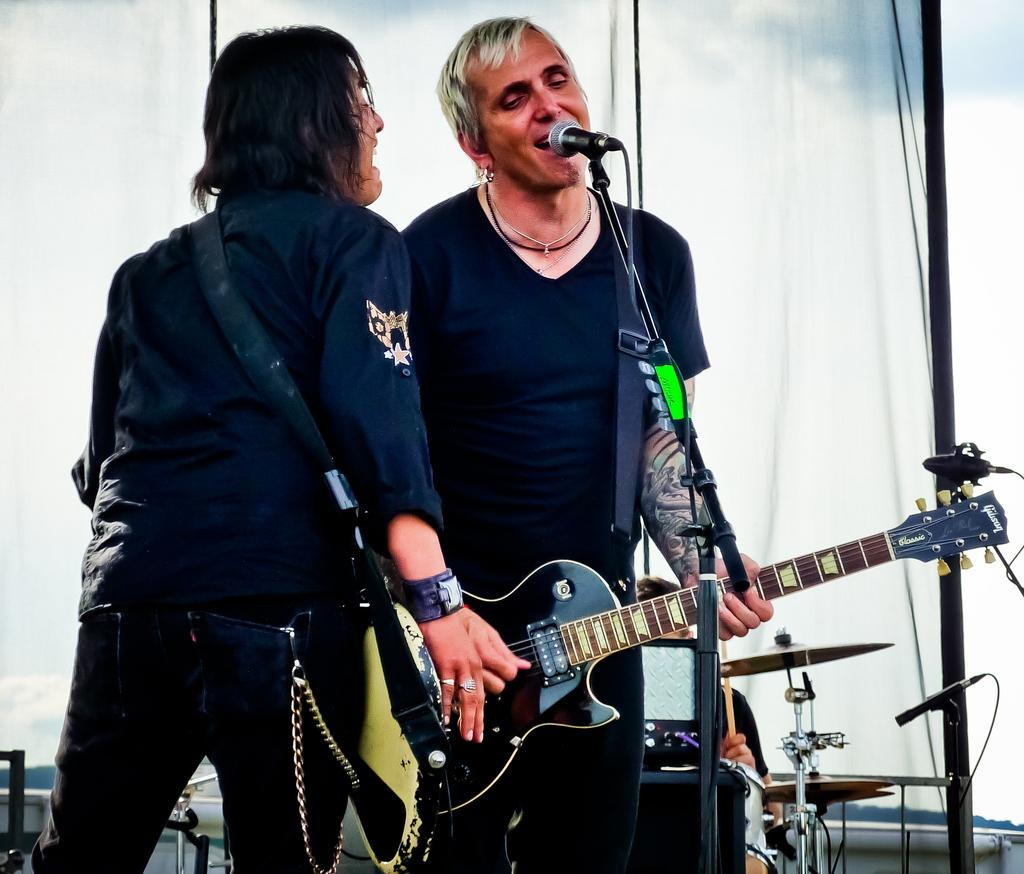How many people are in the image? There are two persons in the image. Where are the two persons located? The two persons are standing on a stage. What are the two persons doing on the stage? Both persons are playing musical instruments. Are there any fairies participating in the protest with the women in the image? There are no fairies or protest present in the image; it features two persons playing musical instruments on a stage. 